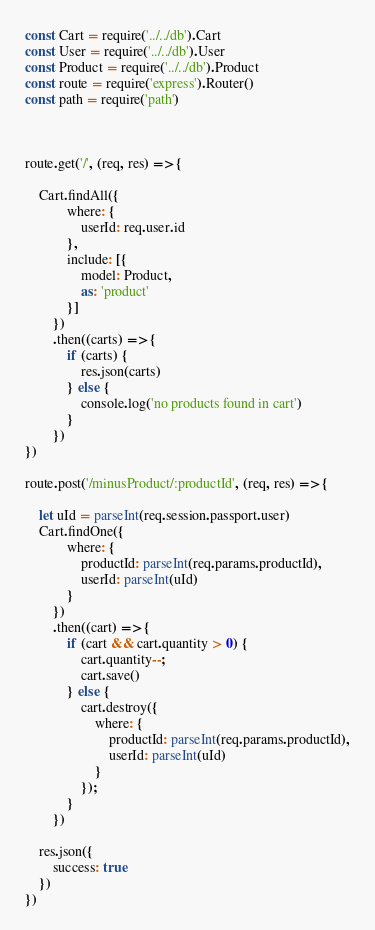<code> <loc_0><loc_0><loc_500><loc_500><_JavaScript_>const Cart = require('../../db').Cart
const User = require('../../db').User
const Product = require('../../db').Product
const route = require('express').Router()
const path = require('path')



route.get('/', (req, res) => {

    Cart.findAll({
            where: {
                userId: req.user.id
            },
            include: [{
                model: Product,
                as: 'product'
            }]
        })
        .then((carts) => {
            if (carts) {
                res.json(carts)
            } else {
                console.log('no products found in cart')
            }
        })
})

route.post('/minusProduct/:productId', (req, res) => {

    let uId = parseInt(req.session.passport.user)
    Cart.findOne({
            where: {
                productId: parseInt(req.params.productId),
                userId: parseInt(uId)
            }
        })
        .then((cart) => {
            if (cart && cart.quantity > 0) {
                cart.quantity--;
                cart.save()
            } else {
                cart.destroy({
                    where: {
                        productId: parseInt(req.params.productId),
                        userId: parseInt(uId)
                    }
                });
            }
        })

    res.json({
        success: true
    })
})

</code> 